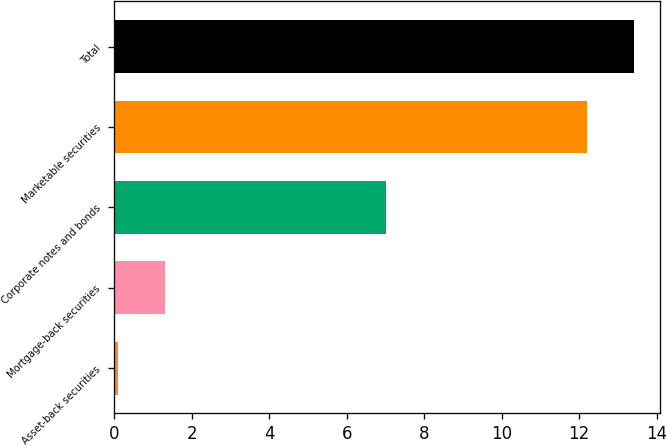Convert chart to OTSL. <chart><loc_0><loc_0><loc_500><loc_500><bar_chart><fcel>Asset-back securities<fcel>Mortgage-back securities<fcel>Corporate notes and bonds<fcel>Marketable securities<fcel>Total<nl><fcel>0.1<fcel>1.31<fcel>7<fcel>12.2<fcel>13.41<nl></chart> 